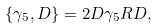<formula> <loc_0><loc_0><loc_500><loc_500>\{ \gamma _ { 5 } , D \} = 2 D \gamma _ { 5 } R D ,</formula> 